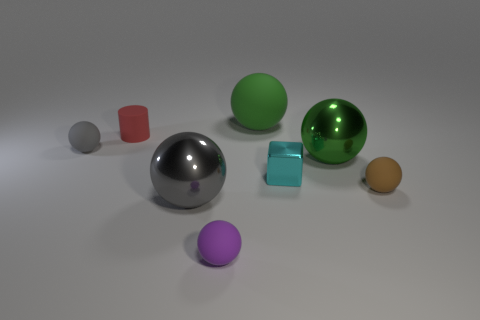Subtract all gray balls. How many balls are left? 4 Subtract all small gray balls. How many balls are left? 5 Subtract all blue balls. Subtract all cyan cylinders. How many balls are left? 6 Add 1 small purple cubes. How many objects exist? 9 Subtract all spheres. How many objects are left? 2 Subtract 0 gray blocks. How many objects are left? 8 Subtract all tiny gray rubber balls. Subtract all big green objects. How many objects are left? 5 Add 5 big matte objects. How many big matte objects are left? 6 Add 5 large cyan matte objects. How many large cyan matte objects exist? 5 